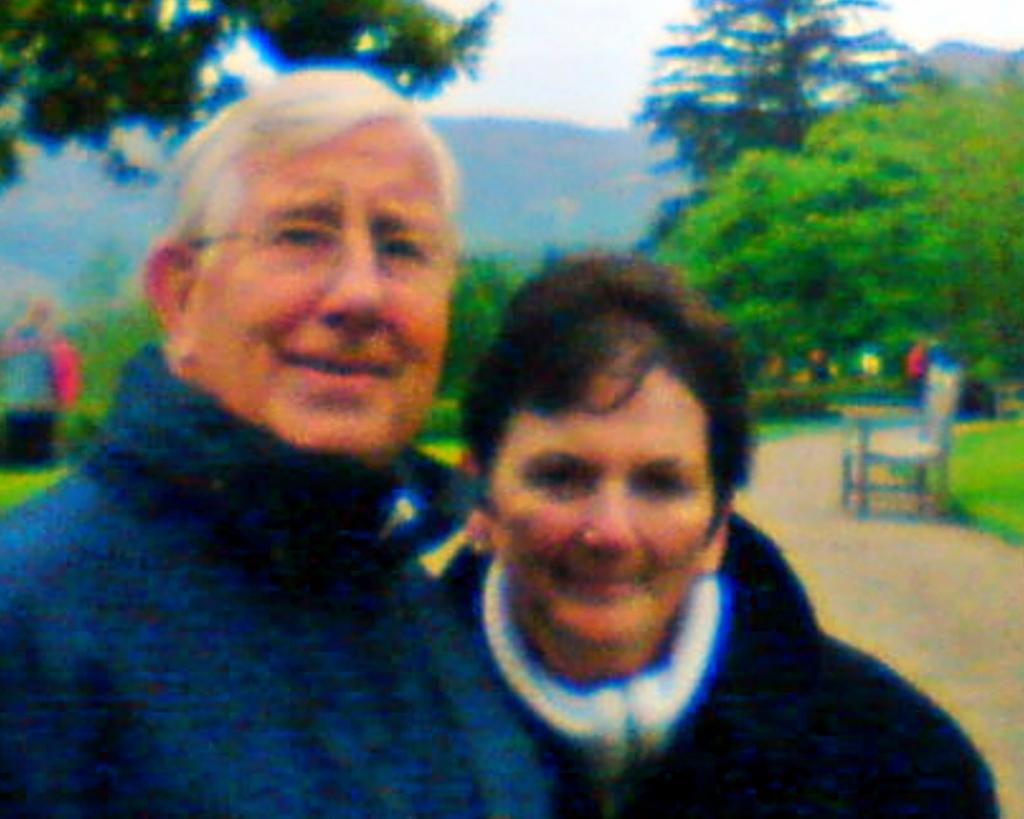Who are the people in the image? There is an old man and a woman in the image. What are the expressions on their faces? Both the old man and the woman are smiling in the image. What are they doing in the image? They are giving a pose into the camera. Can you describe the background of the image? There is a blurred background in the image, and trees are visible in the background. What type of shoes is the old man wearing in the image? There is no information about the shoes the old man is wearing in the image. What are they eating for lunch in the image? There is no mention of lunch or any food in the image. 